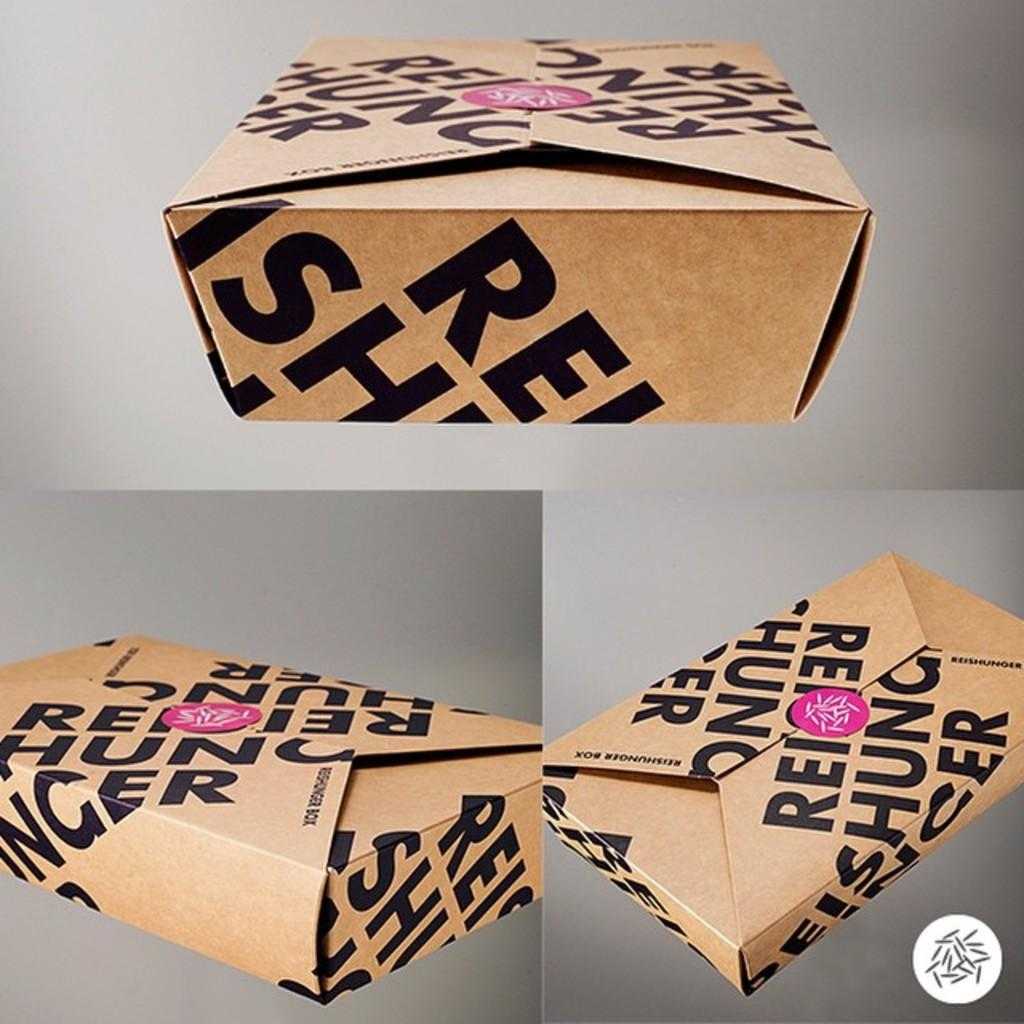<image>
Provide a brief description of the given image. a tan box with black writing by reishunoir box 